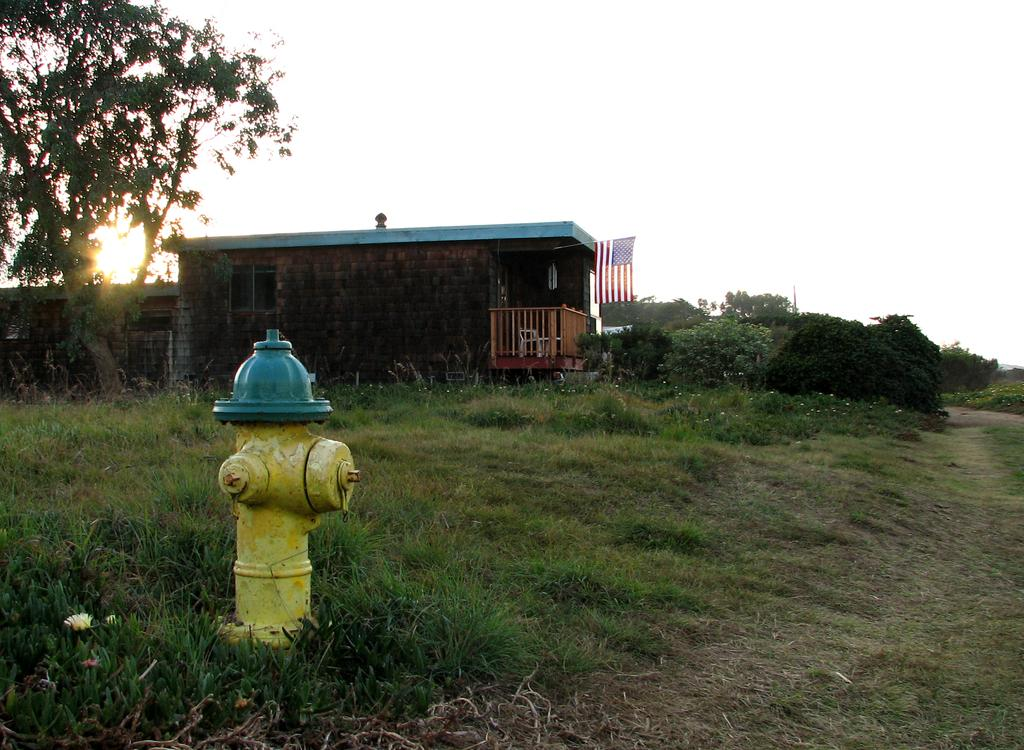What is the main object in the image? There is a hydrant in the image. What type of vegetation can be seen in the image? There is grass, trees, and flowers in the image. What other structures or objects are present in the image? There is a flag, a railing, and a house in the image. What can be seen in the background of the image? The sky is visible in the background of the image. How does the queen react to the heat in the image? There is no queen present in the image, and therefore no reaction to the heat can be observed. 